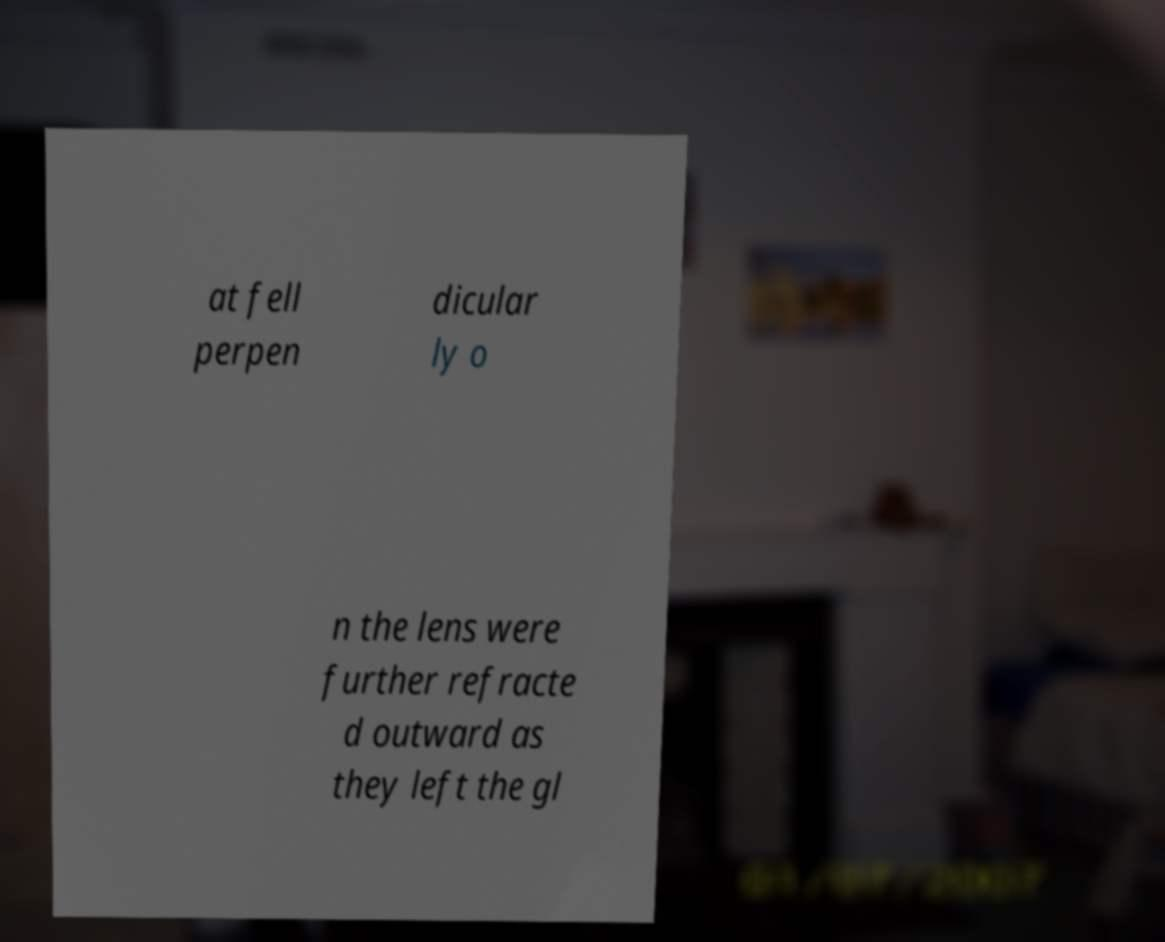Can you accurately transcribe the text from the provided image for me? at fell perpen dicular ly o n the lens were further refracte d outward as they left the gl 